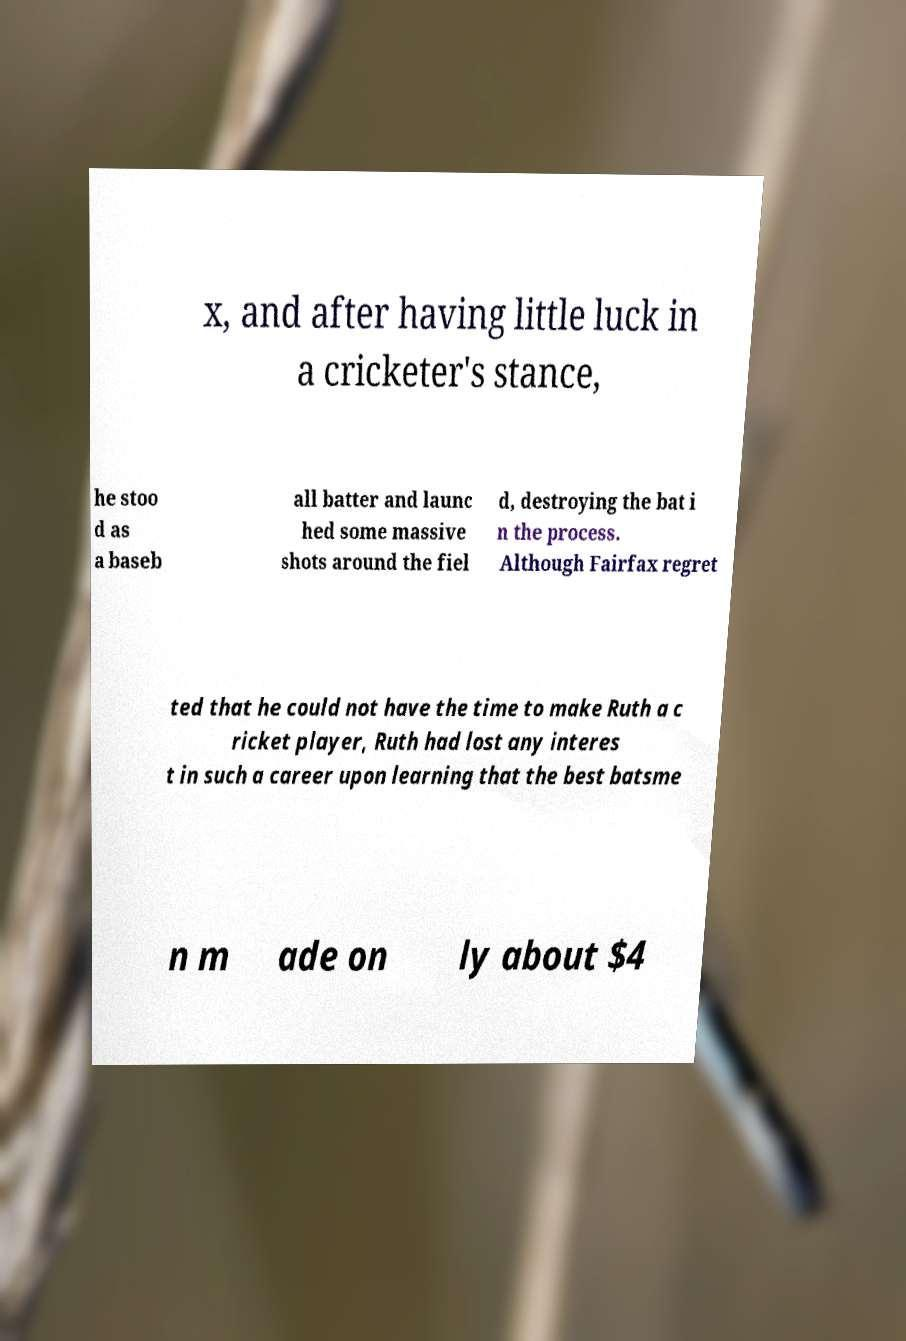Please identify and transcribe the text found in this image. x, and after having little luck in a cricketer's stance, he stoo d as a baseb all batter and launc hed some massive shots around the fiel d, destroying the bat i n the process. Although Fairfax regret ted that he could not have the time to make Ruth a c ricket player, Ruth had lost any interes t in such a career upon learning that the best batsme n m ade on ly about $4 